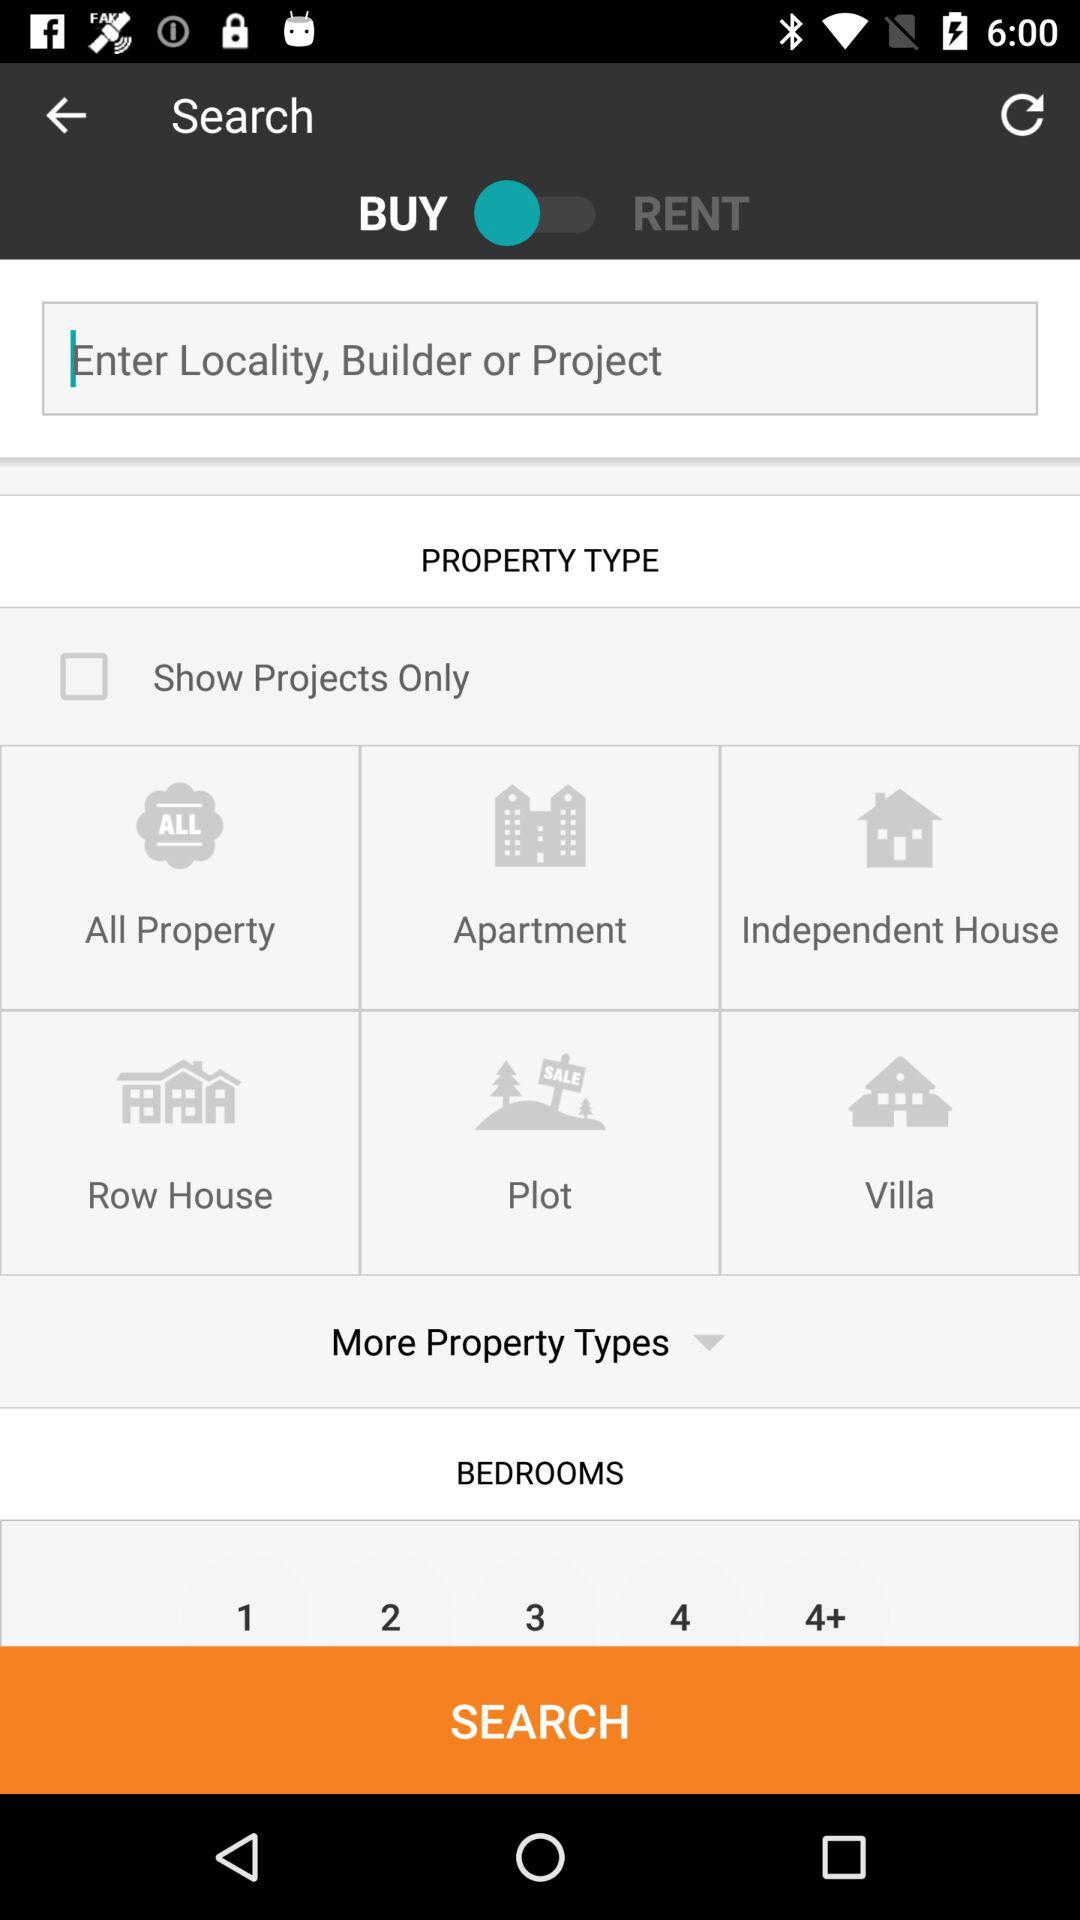What is the status of "BUY"? The status is "on". 